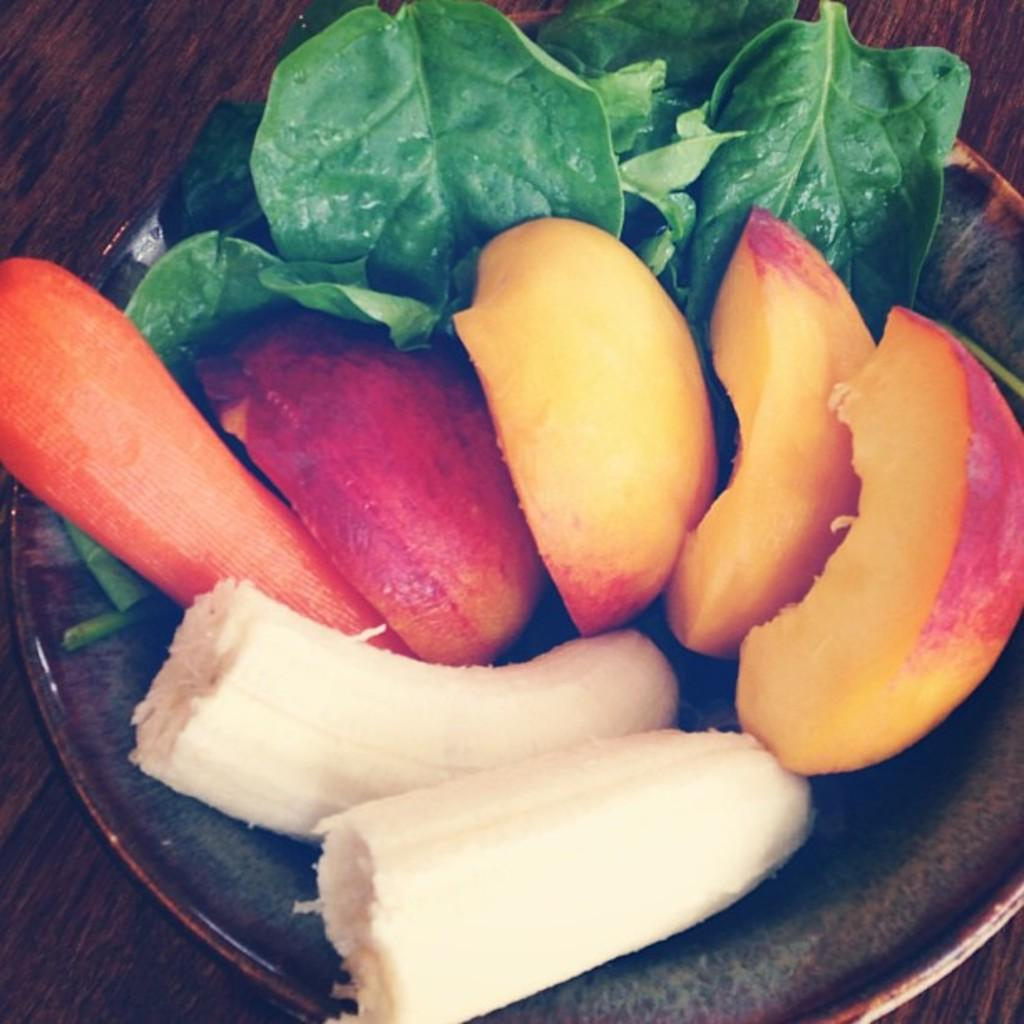What is on the plate in the image? There are four pieces of an apple and two pieces of a banana on the plate. What other object is present on the plate? There is a carrot-like object on the plate. Can you describe the green leaves visible in the image? The green leaves are not on the plate but are visible in the image. What is the bear's reaction to the lock in the image? There is no bear or lock present in the image. 